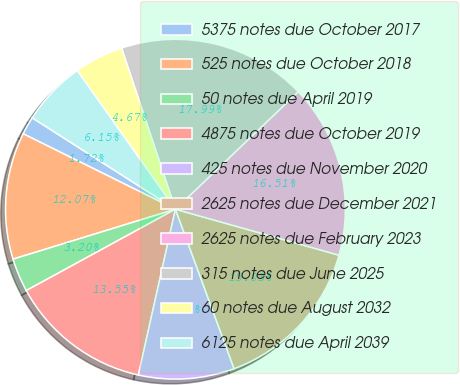<chart> <loc_0><loc_0><loc_500><loc_500><pie_chart><fcel>5375 notes due October 2017<fcel>525 notes due October 2018<fcel>50 notes due April 2019<fcel>4875 notes due October 2019<fcel>425 notes due November 2020<fcel>2625 notes due December 2021<fcel>2625 notes due February 2023<fcel>315 notes due June 2025<fcel>60 notes due August 2032<fcel>6125 notes due April 2039<nl><fcel>1.72%<fcel>12.07%<fcel>3.2%<fcel>13.55%<fcel>9.11%<fcel>15.03%<fcel>16.51%<fcel>17.99%<fcel>4.67%<fcel>6.15%<nl></chart> 